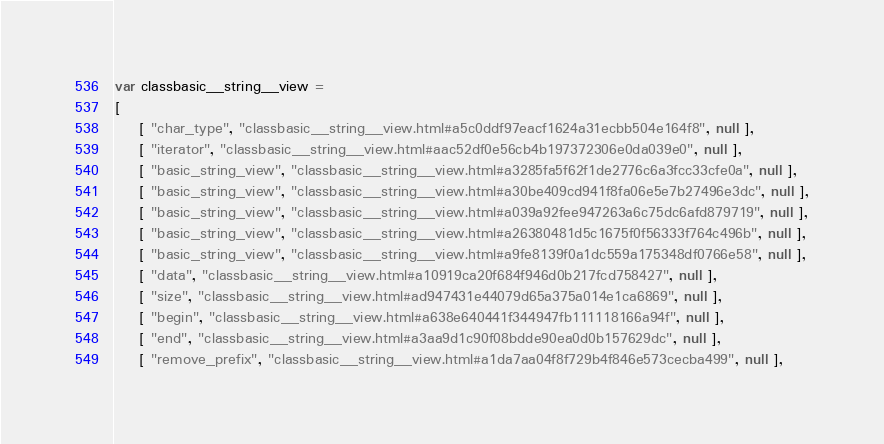Convert code to text. <code><loc_0><loc_0><loc_500><loc_500><_JavaScript_>var classbasic__string__view =
[
    [ "char_type", "classbasic__string__view.html#a5c0ddf97eacf1624a31ecbb504e164f8", null ],
    [ "iterator", "classbasic__string__view.html#aac52df0e56cb4b197372306e0da039e0", null ],
    [ "basic_string_view", "classbasic__string__view.html#a3285fa5f62f1de2776c6a3fcc33cfe0a", null ],
    [ "basic_string_view", "classbasic__string__view.html#a30be409cd941f8fa06e5e7b27496e3dc", null ],
    [ "basic_string_view", "classbasic__string__view.html#a039a92fee947263a6c75dc6afd879719", null ],
    [ "basic_string_view", "classbasic__string__view.html#a26380481d5c1675f0f56333f764c496b", null ],
    [ "basic_string_view", "classbasic__string__view.html#a9fe8139f0a1dc559a175348df0766e58", null ],
    [ "data", "classbasic__string__view.html#a10919ca20f684f946d0b217fcd758427", null ],
    [ "size", "classbasic__string__view.html#ad947431e44079d65a375a014e1ca6869", null ],
    [ "begin", "classbasic__string__view.html#a638e640441f344947fb111118166a94f", null ],
    [ "end", "classbasic__string__view.html#a3aa9d1c90f08bdde90ea0d0b157629dc", null ],
    [ "remove_prefix", "classbasic__string__view.html#a1da7aa04f8f729b4f846e573cecba499", null ],</code> 